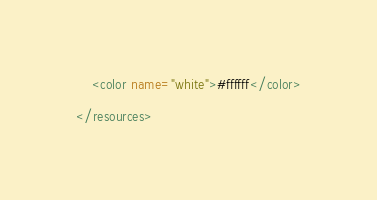<code> <loc_0><loc_0><loc_500><loc_500><_XML_>    <color name="white">#ffffff</color>

</resources>
</code> 